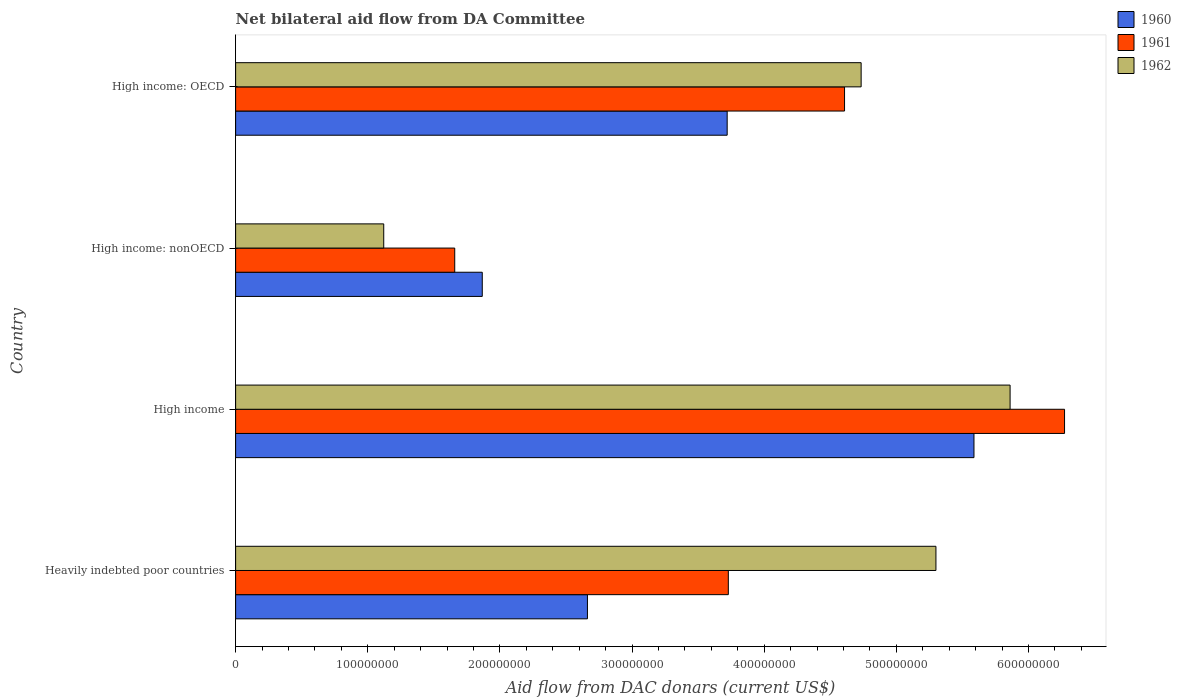How many groups of bars are there?
Your answer should be compact. 4. Are the number of bars on each tick of the Y-axis equal?
Your answer should be very brief. Yes. How many bars are there on the 1st tick from the bottom?
Keep it short and to the point. 3. What is the label of the 3rd group of bars from the top?
Provide a short and direct response. High income. What is the aid flow in in 1962 in Heavily indebted poor countries?
Ensure brevity in your answer.  5.30e+08. Across all countries, what is the maximum aid flow in in 1961?
Your answer should be compact. 6.27e+08. Across all countries, what is the minimum aid flow in in 1961?
Offer a very short reply. 1.66e+08. In which country was the aid flow in in 1961 minimum?
Give a very brief answer. High income: nonOECD. What is the total aid flow in in 1962 in the graph?
Keep it short and to the point. 1.70e+09. What is the difference between the aid flow in in 1960 in High income and that in High income: nonOECD?
Offer a very short reply. 3.72e+08. What is the difference between the aid flow in in 1962 in Heavily indebted poor countries and the aid flow in in 1961 in High income?
Your answer should be very brief. -9.73e+07. What is the average aid flow in in 1960 per country?
Provide a succinct answer. 3.46e+08. What is the difference between the aid flow in in 1961 and aid flow in in 1960 in High income: nonOECD?
Your response must be concise. -2.08e+07. In how many countries, is the aid flow in in 1962 greater than 560000000 US$?
Ensure brevity in your answer.  1. What is the ratio of the aid flow in in 1961 in High income: OECD to that in High income: nonOECD?
Make the answer very short. 2.78. What is the difference between the highest and the second highest aid flow in in 1960?
Make the answer very short. 1.87e+08. What is the difference between the highest and the lowest aid flow in in 1960?
Your response must be concise. 3.72e+08. In how many countries, is the aid flow in in 1960 greater than the average aid flow in in 1960 taken over all countries?
Offer a very short reply. 2. Is the sum of the aid flow in in 1962 in High income and High income: nonOECD greater than the maximum aid flow in in 1960 across all countries?
Make the answer very short. Yes. What does the 2nd bar from the top in Heavily indebted poor countries represents?
Your answer should be very brief. 1961. What does the 2nd bar from the bottom in High income: nonOECD represents?
Your answer should be compact. 1961. Does the graph contain grids?
Provide a succinct answer. No. What is the title of the graph?
Give a very brief answer. Net bilateral aid flow from DA Committee. What is the label or title of the X-axis?
Ensure brevity in your answer.  Aid flow from DAC donars (current US$). What is the Aid flow from DAC donars (current US$) of 1960 in Heavily indebted poor countries?
Ensure brevity in your answer.  2.66e+08. What is the Aid flow from DAC donars (current US$) in 1961 in Heavily indebted poor countries?
Your answer should be compact. 3.73e+08. What is the Aid flow from DAC donars (current US$) in 1962 in Heavily indebted poor countries?
Make the answer very short. 5.30e+08. What is the Aid flow from DAC donars (current US$) in 1960 in High income?
Ensure brevity in your answer.  5.59e+08. What is the Aid flow from DAC donars (current US$) in 1961 in High income?
Give a very brief answer. 6.27e+08. What is the Aid flow from DAC donars (current US$) of 1962 in High income?
Your answer should be very brief. 5.86e+08. What is the Aid flow from DAC donars (current US$) in 1960 in High income: nonOECD?
Your answer should be compact. 1.87e+08. What is the Aid flow from DAC donars (current US$) in 1961 in High income: nonOECD?
Make the answer very short. 1.66e+08. What is the Aid flow from DAC donars (current US$) of 1962 in High income: nonOECD?
Your answer should be very brief. 1.12e+08. What is the Aid flow from DAC donars (current US$) of 1960 in High income: OECD?
Your answer should be very brief. 3.72e+08. What is the Aid flow from DAC donars (current US$) in 1961 in High income: OECD?
Your response must be concise. 4.61e+08. What is the Aid flow from DAC donars (current US$) in 1962 in High income: OECD?
Your answer should be compact. 4.73e+08. Across all countries, what is the maximum Aid flow from DAC donars (current US$) in 1960?
Your answer should be very brief. 5.59e+08. Across all countries, what is the maximum Aid flow from DAC donars (current US$) of 1961?
Provide a succinct answer. 6.27e+08. Across all countries, what is the maximum Aid flow from DAC donars (current US$) in 1962?
Offer a very short reply. 5.86e+08. Across all countries, what is the minimum Aid flow from DAC donars (current US$) in 1960?
Ensure brevity in your answer.  1.87e+08. Across all countries, what is the minimum Aid flow from DAC donars (current US$) in 1961?
Your response must be concise. 1.66e+08. Across all countries, what is the minimum Aid flow from DAC donars (current US$) of 1962?
Offer a very short reply. 1.12e+08. What is the total Aid flow from DAC donars (current US$) of 1960 in the graph?
Give a very brief answer. 1.38e+09. What is the total Aid flow from DAC donars (current US$) of 1961 in the graph?
Give a very brief answer. 1.63e+09. What is the total Aid flow from DAC donars (current US$) in 1962 in the graph?
Your answer should be compact. 1.70e+09. What is the difference between the Aid flow from DAC donars (current US$) in 1960 in Heavily indebted poor countries and that in High income?
Ensure brevity in your answer.  -2.92e+08. What is the difference between the Aid flow from DAC donars (current US$) of 1961 in Heavily indebted poor countries and that in High income?
Your response must be concise. -2.54e+08. What is the difference between the Aid flow from DAC donars (current US$) of 1962 in Heavily indebted poor countries and that in High income?
Your response must be concise. -5.61e+07. What is the difference between the Aid flow from DAC donars (current US$) of 1960 in Heavily indebted poor countries and that in High income: nonOECD?
Provide a short and direct response. 7.96e+07. What is the difference between the Aid flow from DAC donars (current US$) in 1961 in Heavily indebted poor countries and that in High income: nonOECD?
Give a very brief answer. 2.07e+08. What is the difference between the Aid flow from DAC donars (current US$) in 1962 in Heavily indebted poor countries and that in High income: nonOECD?
Make the answer very short. 4.18e+08. What is the difference between the Aid flow from DAC donars (current US$) of 1960 in Heavily indebted poor countries and that in High income: OECD?
Give a very brief answer. -1.06e+08. What is the difference between the Aid flow from DAC donars (current US$) of 1961 in Heavily indebted poor countries and that in High income: OECD?
Keep it short and to the point. -8.80e+07. What is the difference between the Aid flow from DAC donars (current US$) of 1962 in Heavily indebted poor countries and that in High income: OECD?
Ensure brevity in your answer.  5.66e+07. What is the difference between the Aid flow from DAC donars (current US$) in 1960 in High income and that in High income: nonOECD?
Ensure brevity in your answer.  3.72e+08. What is the difference between the Aid flow from DAC donars (current US$) of 1961 in High income and that in High income: nonOECD?
Provide a succinct answer. 4.61e+08. What is the difference between the Aid flow from DAC donars (current US$) in 1962 in High income and that in High income: nonOECD?
Keep it short and to the point. 4.74e+08. What is the difference between the Aid flow from DAC donars (current US$) of 1960 in High income and that in High income: OECD?
Make the answer very short. 1.87e+08. What is the difference between the Aid flow from DAC donars (current US$) in 1961 in High income and that in High income: OECD?
Ensure brevity in your answer.  1.66e+08. What is the difference between the Aid flow from DAC donars (current US$) of 1962 in High income and that in High income: OECD?
Provide a short and direct response. 1.13e+08. What is the difference between the Aid flow from DAC donars (current US$) of 1960 in High income: nonOECD and that in High income: OECD?
Keep it short and to the point. -1.85e+08. What is the difference between the Aid flow from DAC donars (current US$) of 1961 in High income: nonOECD and that in High income: OECD?
Your response must be concise. -2.95e+08. What is the difference between the Aid flow from DAC donars (current US$) in 1962 in High income: nonOECD and that in High income: OECD?
Your response must be concise. -3.61e+08. What is the difference between the Aid flow from DAC donars (current US$) of 1960 in Heavily indebted poor countries and the Aid flow from DAC donars (current US$) of 1961 in High income?
Your answer should be compact. -3.61e+08. What is the difference between the Aid flow from DAC donars (current US$) of 1960 in Heavily indebted poor countries and the Aid flow from DAC donars (current US$) of 1962 in High income?
Give a very brief answer. -3.20e+08. What is the difference between the Aid flow from DAC donars (current US$) of 1961 in Heavily indebted poor countries and the Aid flow from DAC donars (current US$) of 1962 in High income?
Make the answer very short. -2.13e+08. What is the difference between the Aid flow from DAC donars (current US$) of 1960 in Heavily indebted poor countries and the Aid flow from DAC donars (current US$) of 1961 in High income: nonOECD?
Keep it short and to the point. 1.00e+08. What is the difference between the Aid flow from DAC donars (current US$) in 1960 in Heavily indebted poor countries and the Aid flow from DAC donars (current US$) in 1962 in High income: nonOECD?
Keep it short and to the point. 1.54e+08. What is the difference between the Aid flow from DAC donars (current US$) of 1961 in Heavily indebted poor countries and the Aid flow from DAC donars (current US$) of 1962 in High income: nonOECD?
Ensure brevity in your answer.  2.61e+08. What is the difference between the Aid flow from DAC donars (current US$) in 1960 in Heavily indebted poor countries and the Aid flow from DAC donars (current US$) in 1961 in High income: OECD?
Make the answer very short. -1.95e+08. What is the difference between the Aid flow from DAC donars (current US$) of 1960 in Heavily indebted poor countries and the Aid flow from DAC donars (current US$) of 1962 in High income: OECD?
Make the answer very short. -2.07e+08. What is the difference between the Aid flow from DAC donars (current US$) of 1961 in Heavily indebted poor countries and the Aid flow from DAC donars (current US$) of 1962 in High income: OECD?
Keep it short and to the point. -1.00e+08. What is the difference between the Aid flow from DAC donars (current US$) in 1960 in High income and the Aid flow from DAC donars (current US$) in 1961 in High income: nonOECD?
Keep it short and to the point. 3.93e+08. What is the difference between the Aid flow from DAC donars (current US$) of 1960 in High income and the Aid flow from DAC donars (current US$) of 1962 in High income: nonOECD?
Ensure brevity in your answer.  4.47e+08. What is the difference between the Aid flow from DAC donars (current US$) of 1961 in High income and the Aid flow from DAC donars (current US$) of 1962 in High income: nonOECD?
Ensure brevity in your answer.  5.15e+08. What is the difference between the Aid flow from DAC donars (current US$) in 1960 in High income and the Aid flow from DAC donars (current US$) in 1961 in High income: OECD?
Offer a very short reply. 9.79e+07. What is the difference between the Aid flow from DAC donars (current US$) of 1960 in High income and the Aid flow from DAC donars (current US$) of 1962 in High income: OECD?
Offer a very short reply. 8.54e+07. What is the difference between the Aid flow from DAC donars (current US$) in 1961 in High income and the Aid flow from DAC donars (current US$) in 1962 in High income: OECD?
Give a very brief answer. 1.54e+08. What is the difference between the Aid flow from DAC donars (current US$) of 1960 in High income: nonOECD and the Aid flow from DAC donars (current US$) of 1961 in High income: OECD?
Give a very brief answer. -2.74e+08. What is the difference between the Aid flow from DAC donars (current US$) of 1960 in High income: nonOECD and the Aid flow from DAC donars (current US$) of 1962 in High income: OECD?
Your answer should be compact. -2.87e+08. What is the difference between the Aid flow from DAC donars (current US$) in 1961 in High income: nonOECD and the Aid flow from DAC donars (current US$) in 1962 in High income: OECD?
Offer a very short reply. -3.08e+08. What is the average Aid flow from DAC donars (current US$) in 1960 per country?
Your response must be concise. 3.46e+08. What is the average Aid flow from DAC donars (current US$) of 1961 per country?
Your response must be concise. 4.07e+08. What is the average Aid flow from DAC donars (current US$) of 1962 per country?
Ensure brevity in your answer.  4.25e+08. What is the difference between the Aid flow from DAC donars (current US$) in 1960 and Aid flow from DAC donars (current US$) in 1961 in Heavily indebted poor countries?
Offer a terse response. -1.07e+08. What is the difference between the Aid flow from DAC donars (current US$) in 1960 and Aid flow from DAC donars (current US$) in 1962 in Heavily indebted poor countries?
Provide a short and direct response. -2.64e+08. What is the difference between the Aid flow from DAC donars (current US$) in 1961 and Aid flow from DAC donars (current US$) in 1962 in Heavily indebted poor countries?
Provide a succinct answer. -1.57e+08. What is the difference between the Aid flow from DAC donars (current US$) of 1960 and Aid flow from DAC donars (current US$) of 1961 in High income?
Offer a very short reply. -6.85e+07. What is the difference between the Aid flow from DAC donars (current US$) of 1960 and Aid flow from DAC donars (current US$) of 1962 in High income?
Your answer should be compact. -2.73e+07. What is the difference between the Aid flow from DAC donars (current US$) in 1961 and Aid flow from DAC donars (current US$) in 1962 in High income?
Your answer should be compact. 4.12e+07. What is the difference between the Aid flow from DAC donars (current US$) in 1960 and Aid flow from DAC donars (current US$) in 1961 in High income: nonOECD?
Make the answer very short. 2.08e+07. What is the difference between the Aid flow from DAC donars (current US$) of 1960 and Aid flow from DAC donars (current US$) of 1962 in High income: nonOECD?
Provide a succinct answer. 7.46e+07. What is the difference between the Aid flow from DAC donars (current US$) in 1961 and Aid flow from DAC donars (current US$) in 1962 in High income: nonOECD?
Offer a terse response. 5.37e+07. What is the difference between the Aid flow from DAC donars (current US$) in 1960 and Aid flow from DAC donars (current US$) in 1961 in High income: OECD?
Your answer should be compact. -8.88e+07. What is the difference between the Aid flow from DAC donars (current US$) in 1960 and Aid flow from DAC donars (current US$) in 1962 in High income: OECD?
Provide a short and direct response. -1.01e+08. What is the difference between the Aid flow from DAC donars (current US$) in 1961 and Aid flow from DAC donars (current US$) in 1962 in High income: OECD?
Ensure brevity in your answer.  -1.26e+07. What is the ratio of the Aid flow from DAC donars (current US$) of 1960 in Heavily indebted poor countries to that in High income?
Provide a short and direct response. 0.48. What is the ratio of the Aid flow from DAC donars (current US$) in 1961 in Heavily indebted poor countries to that in High income?
Provide a short and direct response. 0.59. What is the ratio of the Aid flow from DAC donars (current US$) of 1962 in Heavily indebted poor countries to that in High income?
Your response must be concise. 0.9. What is the ratio of the Aid flow from DAC donars (current US$) in 1960 in Heavily indebted poor countries to that in High income: nonOECD?
Your response must be concise. 1.43. What is the ratio of the Aid flow from DAC donars (current US$) of 1961 in Heavily indebted poor countries to that in High income: nonOECD?
Provide a short and direct response. 2.25. What is the ratio of the Aid flow from DAC donars (current US$) of 1962 in Heavily indebted poor countries to that in High income: nonOECD?
Keep it short and to the point. 4.73. What is the ratio of the Aid flow from DAC donars (current US$) in 1960 in Heavily indebted poor countries to that in High income: OECD?
Provide a succinct answer. 0.72. What is the ratio of the Aid flow from DAC donars (current US$) in 1961 in Heavily indebted poor countries to that in High income: OECD?
Give a very brief answer. 0.81. What is the ratio of the Aid flow from DAC donars (current US$) of 1962 in Heavily indebted poor countries to that in High income: OECD?
Offer a very short reply. 1.12. What is the ratio of the Aid flow from DAC donars (current US$) of 1960 in High income to that in High income: nonOECD?
Offer a terse response. 2.99. What is the ratio of the Aid flow from DAC donars (current US$) in 1961 in High income to that in High income: nonOECD?
Keep it short and to the point. 3.78. What is the ratio of the Aid flow from DAC donars (current US$) of 1962 in High income to that in High income: nonOECD?
Provide a succinct answer. 5.23. What is the ratio of the Aid flow from DAC donars (current US$) of 1960 in High income to that in High income: OECD?
Your answer should be compact. 1.5. What is the ratio of the Aid flow from DAC donars (current US$) of 1961 in High income to that in High income: OECD?
Offer a terse response. 1.36. What is the ratio of the Aid flow from DAC donars (current US$) of 1962 in High income to that in High income: OECD?
Your response must be concise. 1.24. What is the ratio of the Aid flow from DAC donars (current US$) of 1960 in High income: nonOECD to that in High income: OECD?
Keep it short and to the point. 0.5. What is the ratio of the Aid flow from DAC donars (current US$) in 1961 in High income: nonOECD to that in High income: OECD?
Your response must be concise. 0.36. What is the ratio of the Aid flow from DAC donars (current US$) of 1962 in High income: nonOECD to that in High income: OECD?
Your response must be concise. 0.24. What is the difference between the highest and the second highest Aid flow from DAC donars (current US$) in 1960?
Your answer should be compact. 1.87e+08. What is the difference between the highest and the second highest Aid flow from DAC donars (current US$) in 1961?
Keep it short and to the point. 1.66e+08. What is the difference between the highest and the second highest Aid flow from DAC donars (current US$) of 1962?
Provide a succinct answer. 5.61e+07. What is the difference between the highest and the lowest Aid flow from DAC donars (current US$) in 1960?
Your answer should be very brief. 3.72e+08. What is the difference between the highest and the lowest Aid flow from DAC donars (current US$) of 1961?
Your answer should be very brief. 4.61e+08. What is the difference between the highest and the lowest Aid flow from DAC donars (current US$) in 1962?
Give a very brief answer. 4.74e+08. 